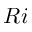<formula> <loc_0><loc_0><loc_500><loc_500>R i</formula> 